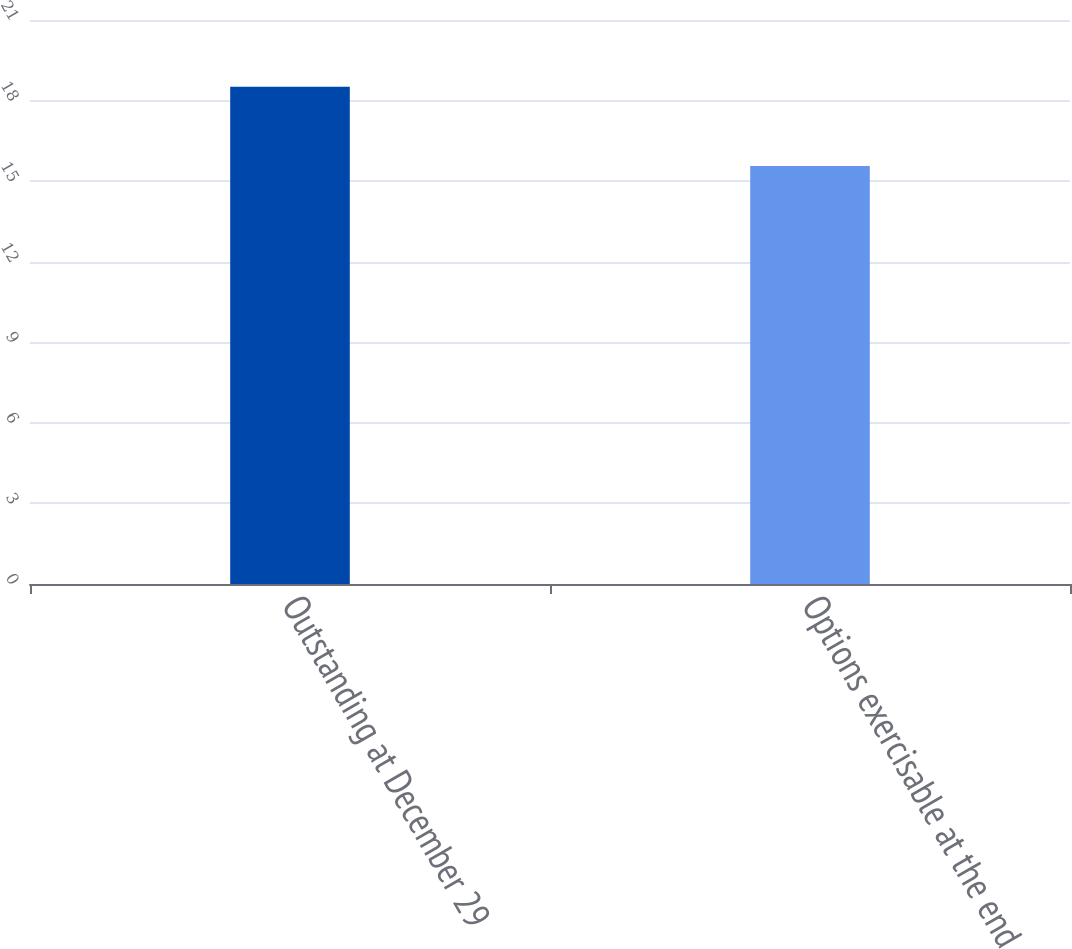<chart> <loc_0><loc_0><loc_500><loc_500><bar_chart><fcel>Outstanding at December 29<fcel>Options exercisable at the end<nl><fcel>18.51<fcel>15.56<nl></chart> 